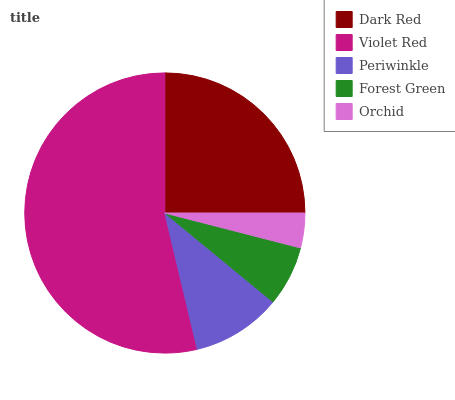Is Orchid the minimum?
Answer yes or no. Yes. Is Violet Red the maximum?
Answer yes or no. Yes. Is Periwinkle the minimum?
Answer yes or no. No. Is Periwinkle the maximum?
Answer yes or no. No. Is Violet Red greater than Periwinkle?
Answer yes or no. Yes. Is Periwinkle less than Violet Red?
Answer yes or no. Yes. Is Periwinkle greater than Violet Red?
Answer yes or no. No. Is Violet Red less than Periwinkle?
Answer yes or no. No. Is Periwinkle the high median?
Answer yes or no. Yes. Is Periwinkle the low median?
Answer yes or no. Yes. Is Forest Green the high median?
Answer yes or no. No. Is Dark Red the low median?
Answer yes or no. No. 